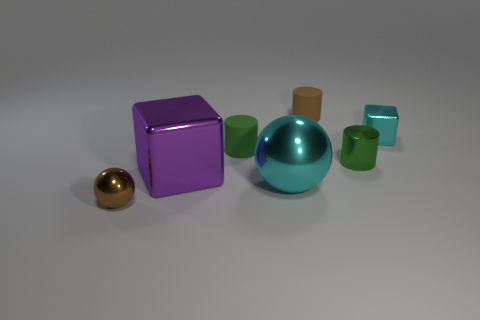Subtract all blue spheres. How many green cylinders are left? 2 Subtract all small rubber cylinders. How many cylinders are left? 1 Add 2 small green metal objects. How many objects exist? 9 Subtract all blocks. How many objects are left? 5 Subtract all yellow cylinders. Subtract all purple cubes. How many cylinders are left? 3 Subtract 0 gray cylinders. How many objects are left? 7 Subtract all large cubes. Subtract all gray metal cylinders. How many objects are left? 6 Add 4 purple metal blocks. How many purple metal blocks are left? 5 Add 3 brown balls. How many brown balls exist? 4 